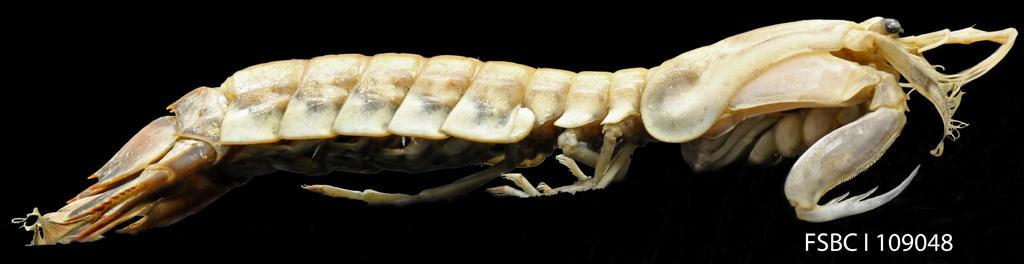What type of creature is present in the image? There is an animal in the image. What else can be seen in the image besides the animal? There is text and numbers in the image. How would you describe the background of the image? The background of the image is dark. What advice does the father give to the child in the image? There is no father or child present in the image, so it is not possible to answer that question. 